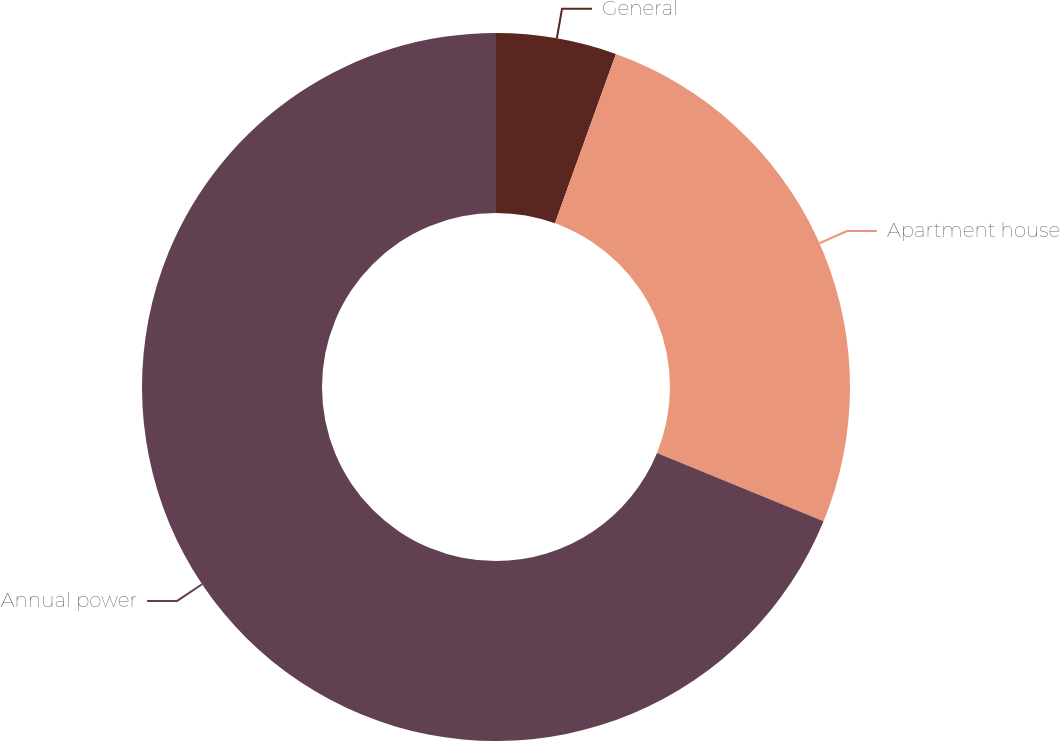<chart> <loc_0><loc_0><loc_500><loc_500><pie_chart><fcel>General<fcel>Apartment house<fcel>Annual power<nl><fcel>5.5%<fcel>25.69%<fcel>68.81%<nl></chart> 